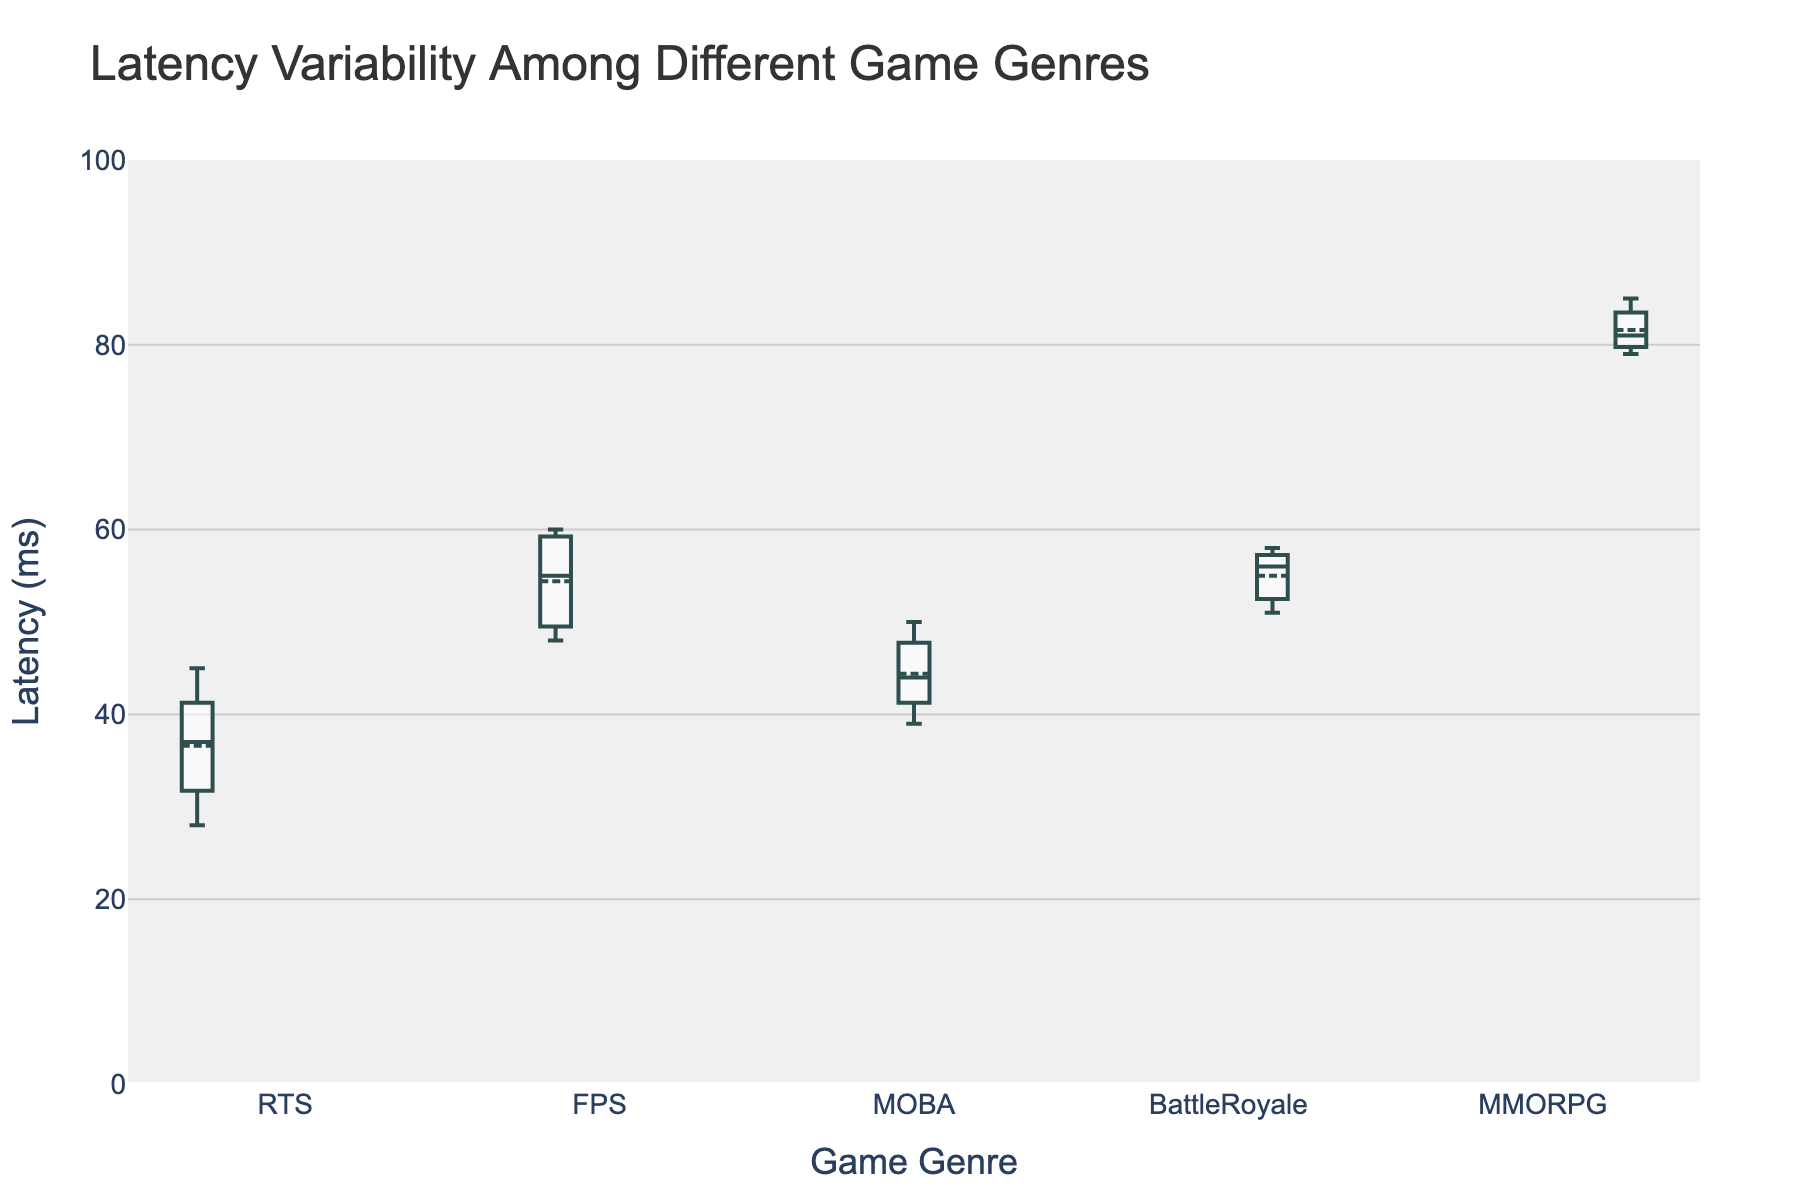What is the title of the box plot? The title of the box plot is usually displayed at the top of the plot. By looking at the figure, you can see the title.
Answer: Latency Variability Among Different Game Genres What is the range of latency in the FPS genre? The range is the difference between the maximum and minimum values. From the box plot, the minimum latency for FPS is around 48 ms, and the maximum is around 60 ms.
Answer: 12 ms Which game genre has the highest median latency? The median latency is indicated by the line within each box on the plot. By comparing the medians across all genres, MMORPG has the highest median.
Answer: MMORPG How does the variability in latency for RTS compare to BattleRoyale? Variability in latency is represented by the spread of the box and whiskers. RTS has a smaller range and interquartile range compared to BattleRoyale, indicating less variability.
Answer: Less variability What are the quartile ranges for the MOBA genre? The first quartile (Q1) and third quartile (Q3) forms the box's edges. For MOBA, Q1 is around 42 ms and Q3 is around 47 ms.
Answer: Q1: 42 ms, Q3: 47 ms Which genre exhibits the widest interquartile range (IQR) of latency? The IQR is the length of the box, representing the range between Q1 and Q3. By comparing, MMORPG has the widest IQR.
Answer: MMORPG What is the approximate median latency for the BattleRoyale genre? The median is shown by the line inside each box. For BattleRoyale, it is around 56 ms.
Answer: 56 ms Which genre shows the lowest minimum latency? The minimum latency is indicated by the bottom whisker. By observing, RTS shows the lowest minimum latency.
Answer: RTS Is the latency for the FPS genre generally higher or lower than the MOBA genre? The medians and overall spread for FPS are higher compared to MOBA, which can be observed through the plot.
Answer: Higher What is the mean latency for the RTS genre? The plot includes a boxmean indicator. For RTS, the mean latency can be inferred from the dot within or near the box, which is around 36.6 ms.
Answer: 36.6 ms 